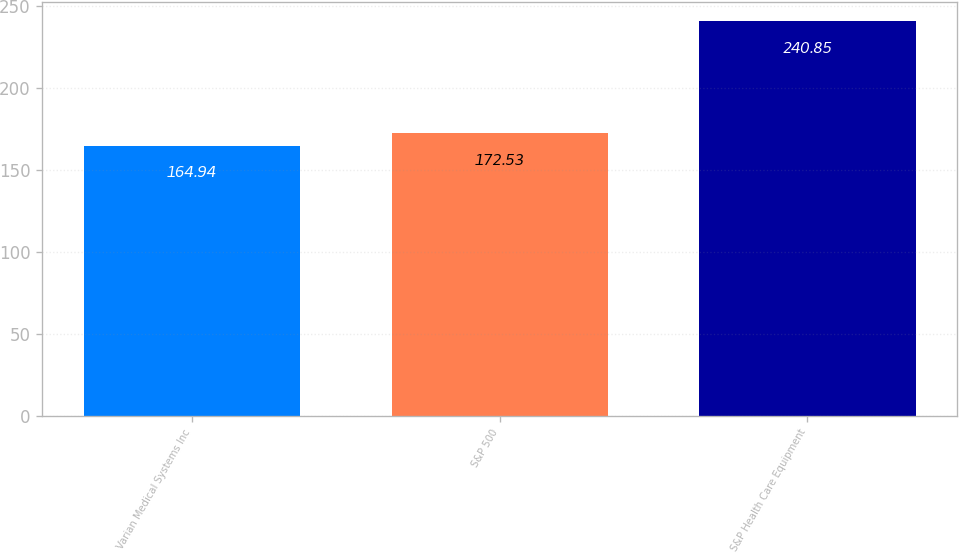<chart> <loc_0><loc_0><loc_500><loc_500><bar_chart><fcel>Varian Medical Systems Inc<fcel>S&P 500<fcel>S&P Health Care Equipment<nl><fcel>164.94<fcel>172.53<fcel>240.85<nl></chart> 